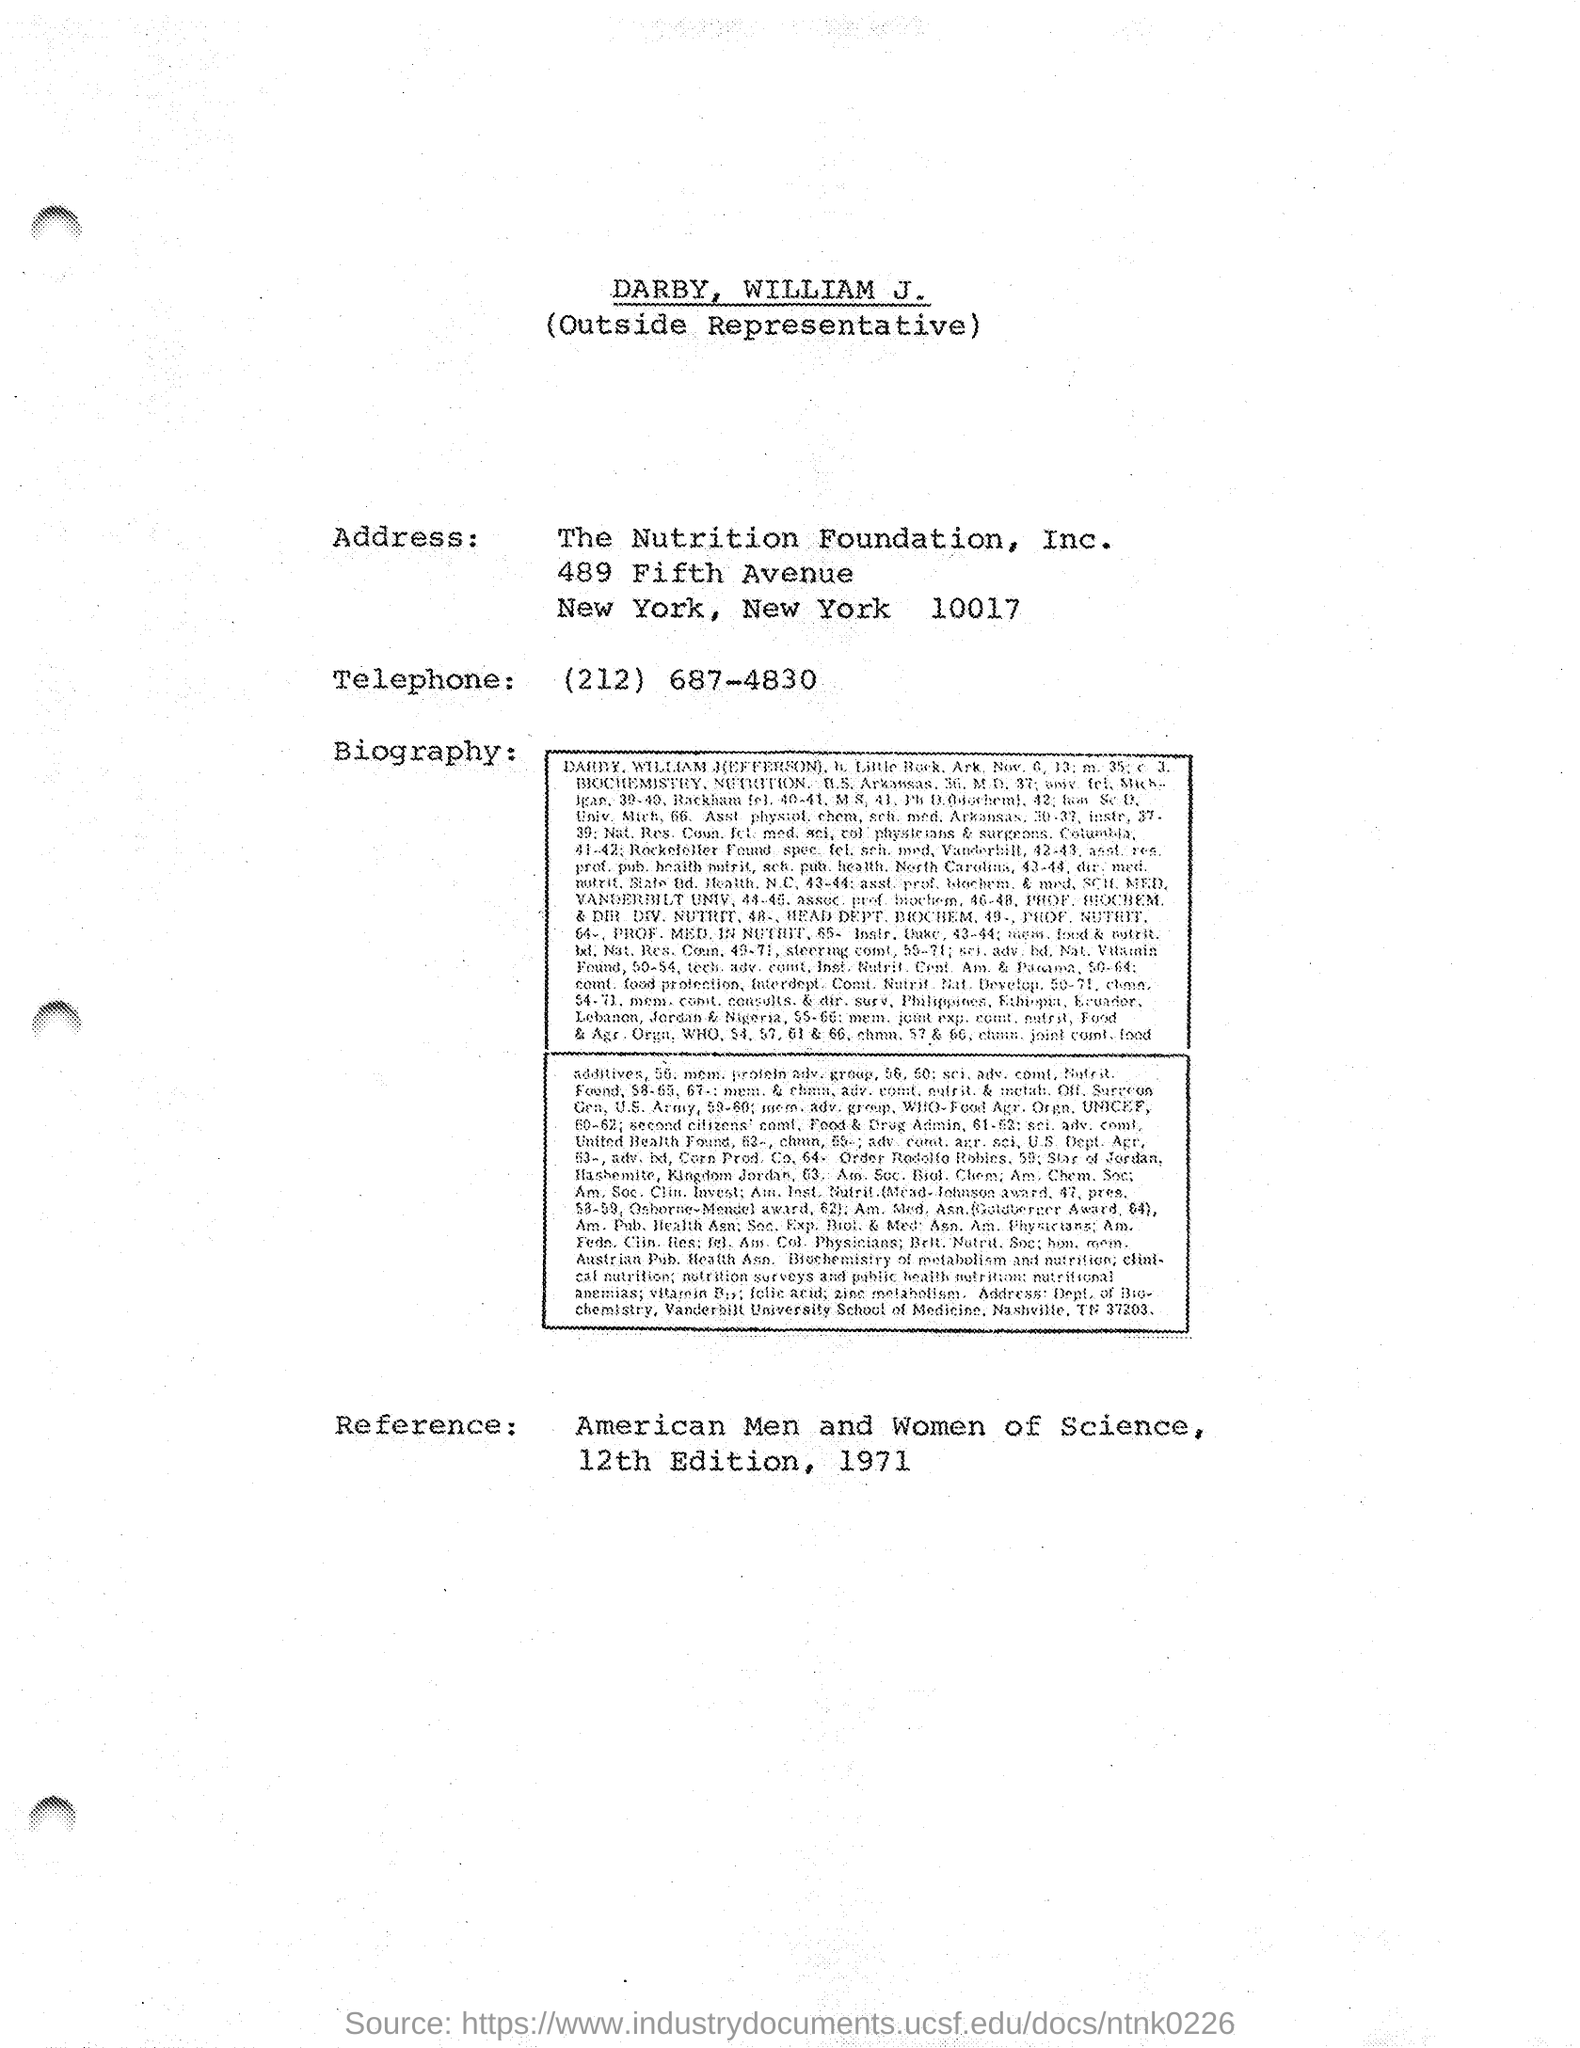Mention a couple of crucial points in this snapshot. The American Men and Women of Science foundation is a prestigious organization recognized for its contributions to the scientific community. The representative of the foundation is William J. DARBY. 